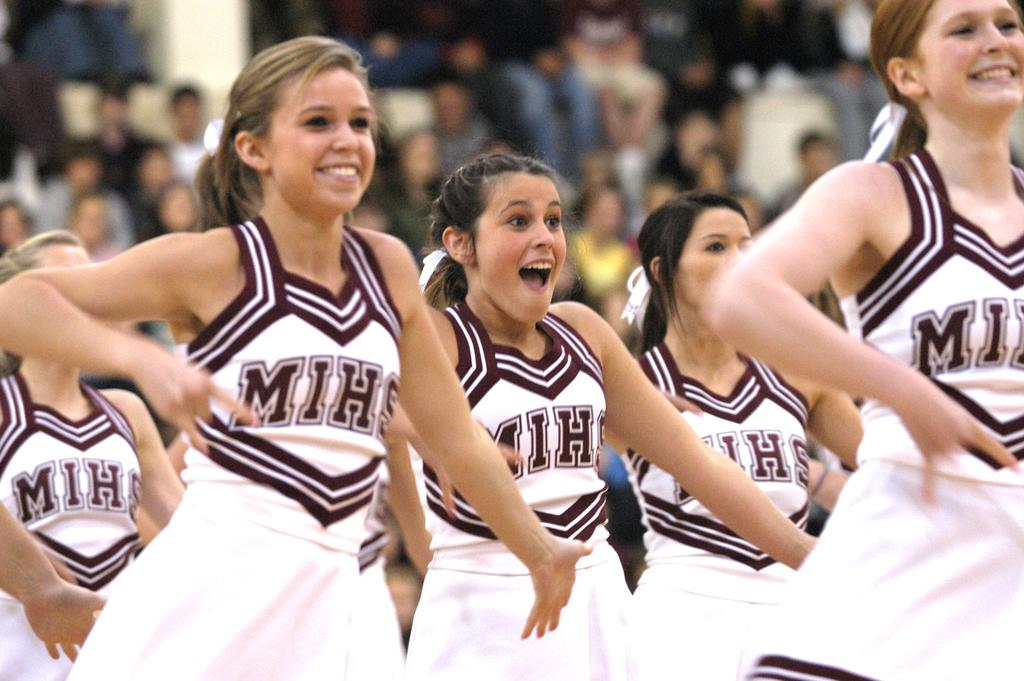<image>
Present a compact description of the photo's key features. Cheerleaders in MIHS uniforms are preforming at a game. 